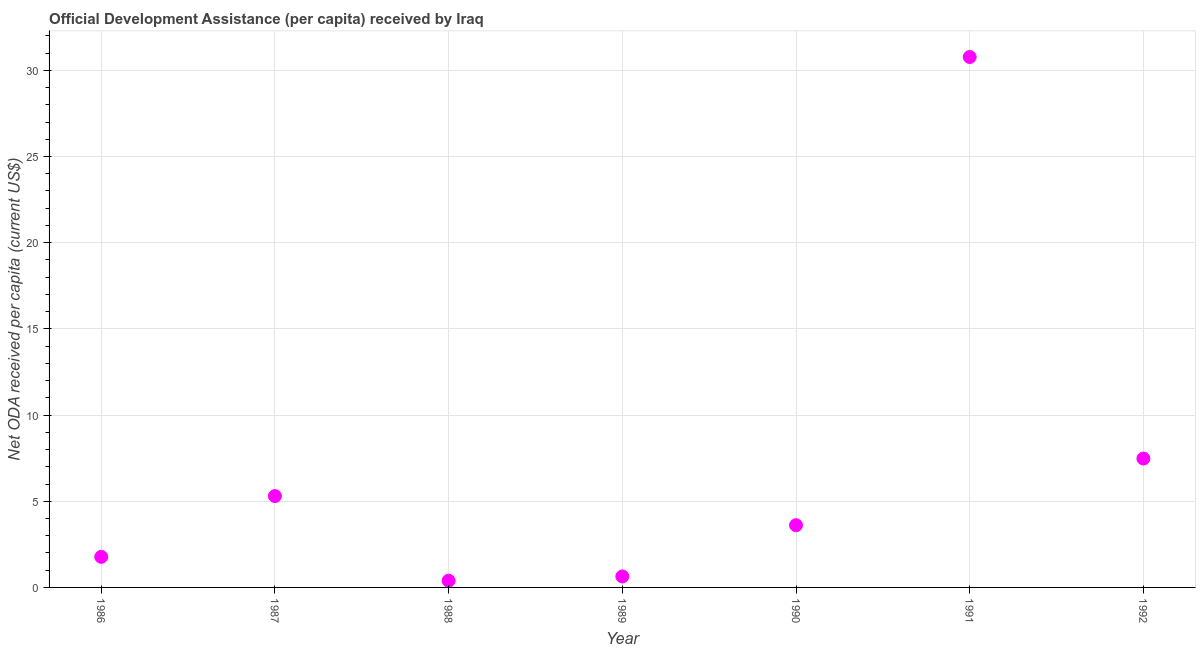What is the net oda received per capita in 1986?
Your answer should be very brief. 1.77. Across all years, what is the maximum net oda received per capita?
Offer a very short reply. 30.77. Across all years, what is the minimum net oda received per capita?
Your response must be concise. 0.39. In which year was the net oda received per capita minimum?
Your answer should be compact. 1988. What is the sum of the net oda received per capita?
Your answer should be compact. 49.96. What is the difference between the net oda received per capita in 1989 and 1990?
Provide a short and direct response. -2.97. What is the average net oda received per capita per year?
Make the answer very short. 7.14. What is the median net oda received per capita?
Provide a succinct answer. 3.61. What is the ratio of the net oda received per capita in 1987 to that in 1989?
Your answer should be very brief. 8.31. What is the difference between the highest and the second highest net oda received per capita?
Ensure brevity in your answer.  23.3. What is the difference between the highest and the lowest net oda received per capita?
Your answer should be very brief. 30.38. In how many years, is the net oda received per capita greater than the average net oda received per capita taken over all years?
Your answer should be compact. 2. How many dotlines are there?
Ensure brevity in your answer.  1. Are the values on the major ticks of Y-axis written in scientific E-notation?
Ensure brevity in your answer.  No. Does the graph contain any zero values?
Provide a short and direct response. No. Does the graph contain grids?
Your answer should be very brief. Yes. What is the title of the graph?
Your answer should be compact. Official Development Assistance (per capita) received by Iraq. What is the label or title of the X-axis?
Ensure brevity in your answer.  Year. What is the label or title of the Y-axis?
Provide a succinct answer. Net ODA received per capita (current US$). What is the Net ODA received per capita (current US$) in 1986?
Your response must be concise. 1.77. What is the Net ODA received per capita (current US$) in 1987?
Offer a terse response. 5.3. What is the Net ODA received per capita (current US$) in 1988?
Offer a terse response. 0.39. What is the Net ODA received per capita (current US$) in 1989?
Your answer should be compact. 0.64. What is the Net ODA received per capita (current US$) in 1990?
Ensure brevity in your answer.  3.61. What is the Net ODA received per capita (current US$) in 1991?
Your response must be concise. 30.77. What is the Net ODA received per capita (current US$) in 1992?
Offer a very short reply. 7.48. What is the difference between the Net ODA received per capita (current US$) in 1986 and 1987?
Your answer should be very brief. -3.53. What is the difference between the Net ODA received per capita (current US$) in 1986 and 1988?
Offer a terse response. 1.38. What is the difference between the Net ODA received per capita (current US$) in 1986 and 1989?
Offer a terse response. 1.14. What is the difference between the Net ODA received per capita (current US$) in 1986 and 1990?
Provide a succinct answer. -1.84. What is the difference between the Net ODA received per capita (current US$) in 1986 and 1991?
Your answer should be very brief. -29. What is the difference between the Net ODA received per capita (current US$) in 1986 and 1992?
Offer a terse response. -5.7. What is the difference between the Net ODA received per capita (current US$) in 1987 and 1988?
Provide a succinct answer. 4.91. What is the difference between the Net ODA received per capita (current US$) in 1987 and 1989?
Your answer should be compact. 4.66. What is the difference between the Net ODA received per capita (current US$) in 1987 and 1990?
Offer a very short reply. 1.69. What is the difference between the Net ODA received per capita (current US$) in 1987 and 1991?
Offer a terse response. -25.47. What is the difference between the Net ODA received per capita (current US$) in 1987 and 1992?
Provide a succinct answer. -2.18. What is the difference between the Net ODA received per capita (current US$) in 1988 and 1989?
Make the answer very short. -0.25. What is the difference between the Net ODA received per capita (current US$) in 1988 and 1990?
Make the answer very short. -3.22. What is the difference between the Net ODA received per capita (current US$) in 1988 and 1991?
Provide a short and direct response. -30.38. What is the difference between the Net ODA received per capita (current US$) in 1988 and 1992?
Ensure brevity in your answer.  -7.09. What is the difference between the Net ODA received per capita (current US$) in 1989 and 1990?
Provide a short and direct response. -2.97. What is the difference between the Net ODA received per capita (current US$) in 1989 and 1991?
Offer a terse response. -30.14. What is the difference between the Net ODA received per capita (current US$) in 1989 and 1992?
Offer a terse response. -6.84. What is the difference between the Net ODA received per capita (current US$) in 1990 and 1991?
Ensure brevity in your answer.  -27.16. What is the difference between the Net ODA received per capita (current US$) in 1990 and 1992?
Your answer should be compact. -3.87. What is the difference between the Net ODA received per capita (current US$) in 1991 and 1992?
Your answer should be compact. 23.3. What is the ratio of the Net ODA received per capita (current US$) in 1986 to that in 1987?
Make the answer very short. 0.34. What is the ratio of the Net ODA received per capita (current US$) in 1986 to that in 1988?
Your answer should be compact. 4.55. What is the ratio of the Net ODA received per capita (current US$) in 1986 to that in 1989?
Your answer should be very brief. 2.78. What is the ratio of the Net ODA received per capita (current US$) in 1986 to that in 1990?
Give a very brief answer. 0.49. What is the ratio of the Net ODA received per capita (current US$) in 1986 to that in 1991?
Give a very brief answer. 0.06. What is the ratio of the Net ODA received per capita (current US$) in 1986 to that in 1992?
Provide a succinct answer. 0.24. What is the ratio of the Net ODA received per capita (current US$) in 1987 to that in 1988?
Keep it short and to the point. 13.58. What is the ratio of the Net ODA received per capita (current US$) in 1987 to that in 1989?
Make the answer very short. 8.31. What is the ratio of the Net ODA received per capita (current US$) in 1987 to that in 1990?
Your answer should be very brief. 1.47. What is the ratio of the Net ODA received per capita (current US$) in 1987 to that in 1991?
Make the answer very short. 0.17. What is the ratio of the Net ODA received per capita (current US$) in 1987 to that in 1992?
Give a very brief answer. 0.71. What is the ratio of the Net ODA received per capita (current US$) in 1988 to that in 1989?
Offer a very short reply. 0.61. What is the ratio of the Net ODA received per capita (current US$) in 1988 to that in 1990?
Provide a short and direct response. 0.11. What is the ratio of the Net ODA received per capita (current US$) in 1988 to that in 1991?
Give a very brief answer. 0.01. What is the ratio of the Net ODA received per capita (current US$) in 1988 to that in 1992?
Your response must be concise. 0.05. What is the ratio of the Net ODA received per capita (current US$) in 1989 to that in 1990?
Make the answer very short. 0.18. What is the ratio of the Net ODA received per capita (current US$) in 1989 to that in 1991?
Ensure brevity in your answer.  0.02. What is the ratio of the Net ODA received per capita (current US$) in 1989 to that in 1992?
Offer a very short reply. 0.09. What is the ratio of the Net ODA received per capita (current US$) in 1990 to that in 1991?
Make the answer very short. 0.12. What is the ratio of the Net ODA received per capita (current US$) in 1990 to that in 1992?
Make the answer very short. 0.48. What is the ratio of the Net ODA received per capita (current US$) in 1991 to that in 1992?
Ensure brevity in your answer.  4.12. 